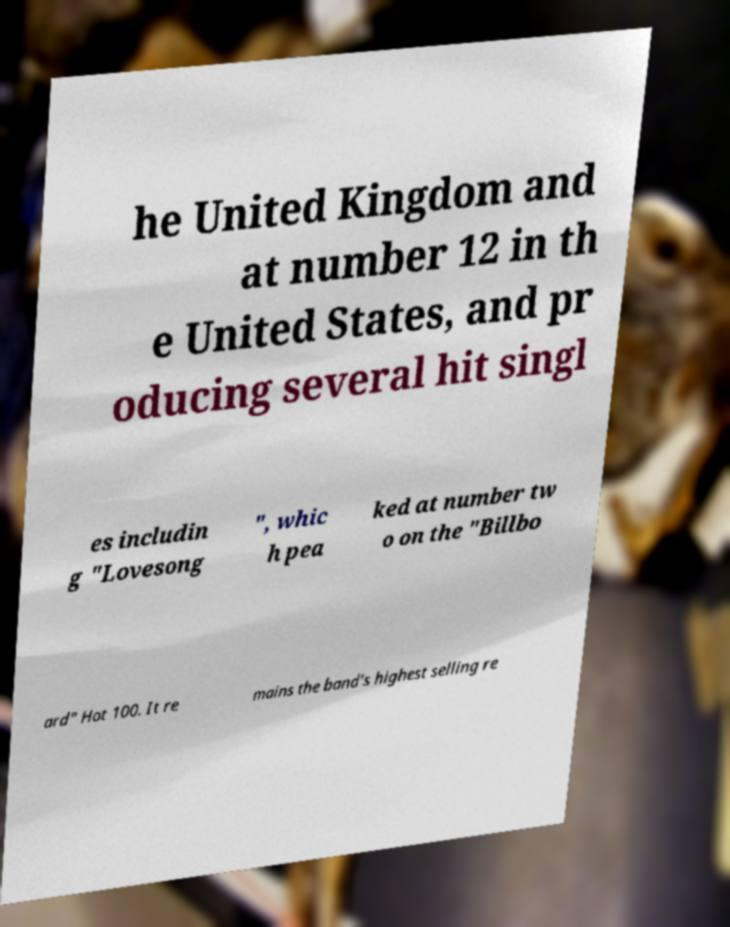I need the written content from this picture converted into text. Can you do that? he United Kingdom and at number 12 in th e United States, and pr oducing several hit singl es includin g "Lovesong ", whic h pea ked at number tw o on the "Billbo ard" Hot 100. It re mains the band’s highest selling re 